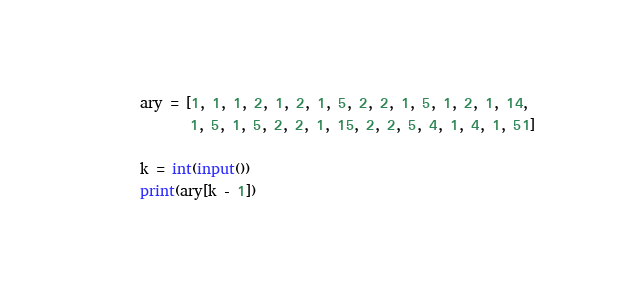<code> <loc_0><loc_0><loc_500><loc_500><_Python_>ary = [1, 1, 1, 2, 1, 2, 1, 5, 2, 2, 1, 5, 1, 2, 1, 14,
       1, 5, 1, 5, 2, 2, 1, 15, 2, 2, 5, 4, 1, 4, 1, 51]

k = int(input())
print(ary[k - 1])
</code> 